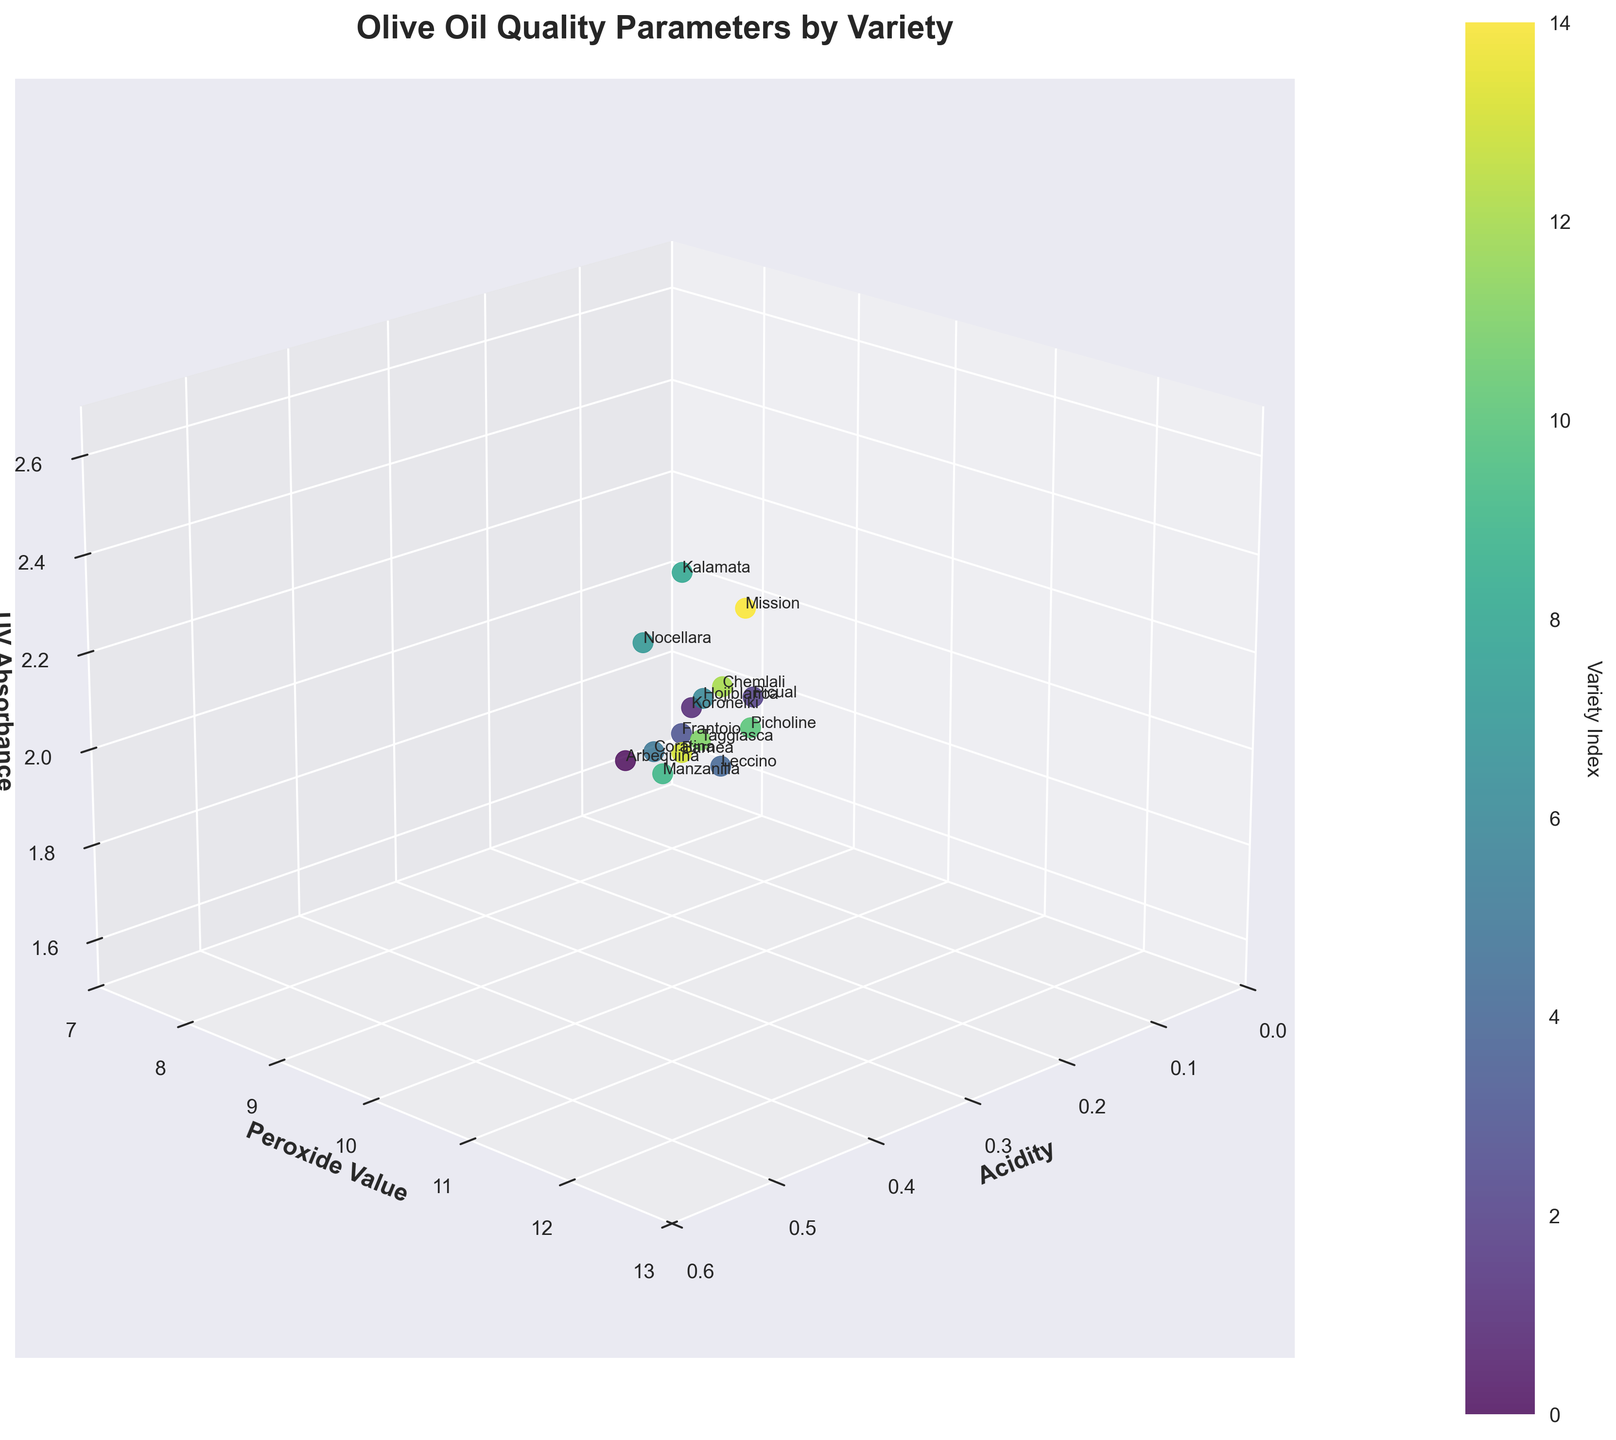What's the title of the figure? The title can be found at the top of the figure in bold text. It reads, "Olive Oil Quality Parameters by Variety".
Answer: Olive Oil Quality Parameters by Variety How many olive varieties are represented in the figure? Each unique data point in the 3D scatter plot corresponds to a different olive variety, and the names are labeled on the plot. You can count the unique labels. There are 15 varieties.
Answer: 15 Which variety has the highest Acidity value? By locating the highest point along the Acidity axis, we find the variety with the highest value in this parameter. Hojiblanca and Mission both have an Acidity value of 0.5.
Answer: Hojiblanca & Mission What is the Peroxide Value for the variety with the lowest Acidity? First, identify the variety with the lowest Acidity value, which is Coratina with an Acidity of 0.1. Next, find the Peroxide Value for Coratina, which is 7.8.
Answer: 7.8 Which variety has the highest UV Absorbance? Locate the highest point along the UV Absorbance axis. The variety corresponding to this point is Mission, with a UV Absorbance of 2.6.
Answer: Mission What is the average UV Absorbance for all the varieties? Sum all UV Absorbance values for each variety (1.8+2.1+2.3+1.9+2.0+1.7+2.4+2.2+2.5+1.8+2.1+1.9+2.3+2.0+2.6) and divide by the number of varieties (15). This equals (32.7/15), which is approximately 2.18.
Answer: 2.18 Which variety has the lowest Peroxide Value and what is its UV Absorbance? Find the point with the lowest Peroxide Value which is Coratina, then check the corresponding UV Absorbance value, which is 1.7.
Answer: Coratina, 1.7 Is there a variety with Acidity of 0.2 and if so, what are its Peroxide Value and UV Absorbance? Check the plot for points with an Acidity of 0.2. Arbequina, Frantoio, Manzanilla, and Taggiasca all have this Acidity. Their Peroxide Values and UV Absorbance are: Arbequina (8.5, 1.8), Frantoio (9.1, 1.9), Manzanilla (8.9, 1.8), Taggiasca (9.3, 1.9).
Answer: Arbequina: 8.5, 1.8; Frantoio: 9.1, 1.9; Manzanilla: 8.9, 1.8; Taggiasca: 9.3, 1.9 Which variety has a higher Peroxide Value, Leccino or Barnea? Compare the Peroxide Values of Leccino (10.5) and Barnea (10.1). Leccino has a higher Peroxide Value.
Answer: Leccino 